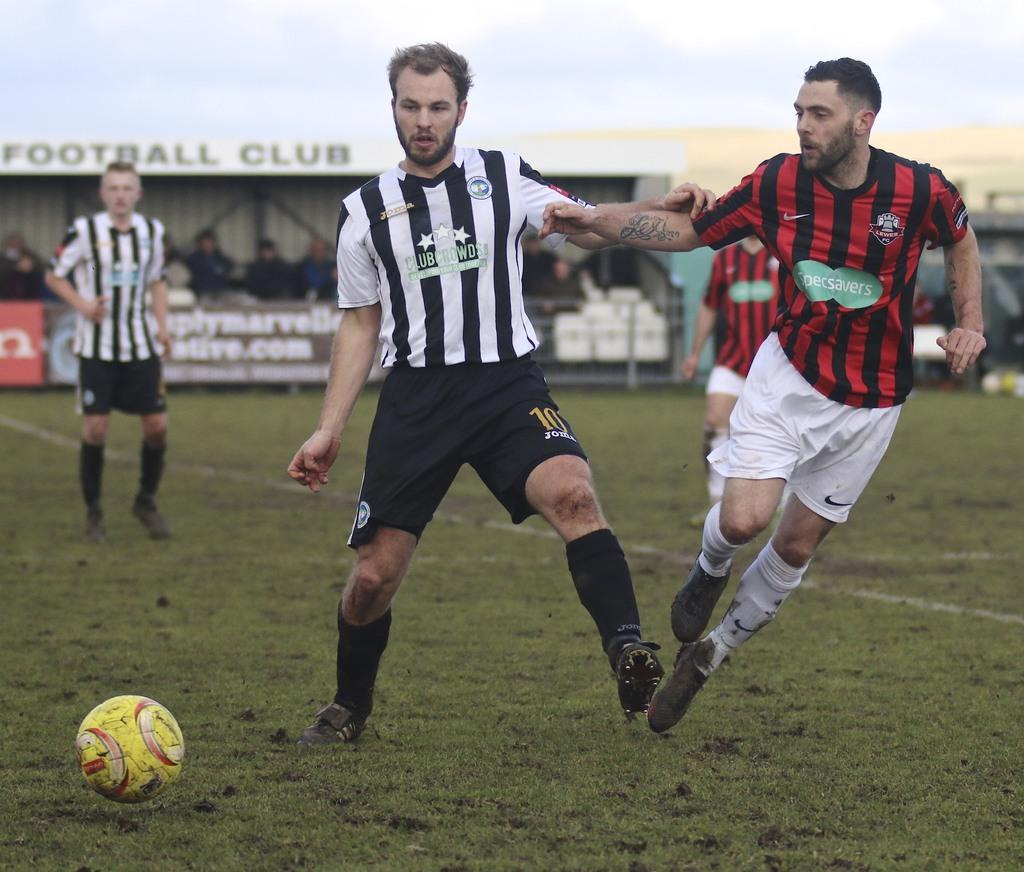<image>
Give a short and clear explanation of the subsequent image. A soccer player wearing a white and black Clubcrowds jersey is blocking a player in a red and black Specsavers jersey. 